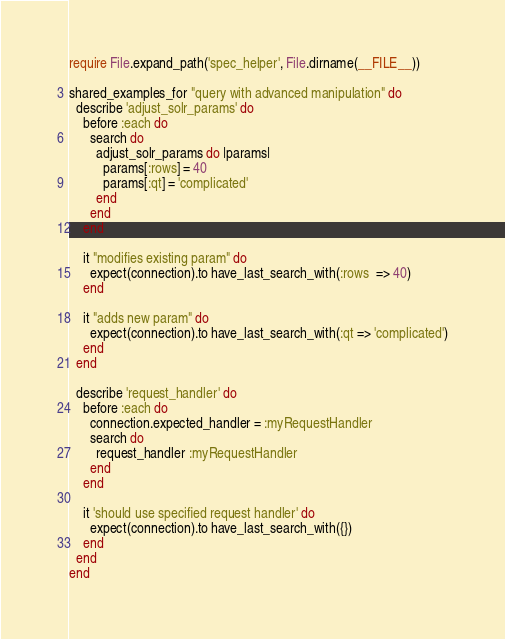<code> <loc_0><loc_0><loc_500><loc_500><_Ruby_>require File.expand_path('spec_helper', File.dirname(__FILE__))

shared_examples_for "query with advanced manipulation" do
  describe 'adjust_solr_params' do
    before :each do
      search do
        adjust_solr_params do |params|
          params[:rows] = 40
          params[:qt] = 'complicated'
        end
      end
    end

    it "modifies existing param" do
      expect(connection).to have_last_search_with(:rows  => 40)
    end

    it "adds new param" do
      expect(connection).to have_last_search_with(:qt => 'complicated')
    end
  end

  describe 'request_handler' do
    before :each do
      connection.expected_handler = :myRequestHandler
      search do
        request_handler :myRequestHandler
      end
    end

    it 'should use specified request handler' do
      expect(connection).to have_last_search_with({})
    end
  end
end
</code> 